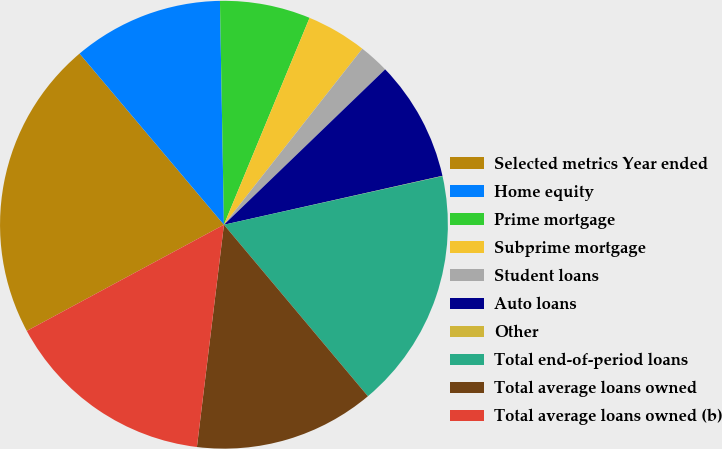Convert chart to OTSL. <chart><loc_0><loc_0><loc_500><loc_500><pie_chart><fcel>Selected metrics Year ended<fcel>Home equity<fcel>Prime mortgage<fcel>Subprime mortgage<fcel>Student loans<fcel>Auto loans<fcel>Other<fcel>Total end-of-period loans<fcel>Total average loans owned<fcel>Total average loans owned (b)<nl><fcel>21.71%<fcel>10.87%<fcel>6.53%<fcel>4.36%<fcel>2.19%<fcel>8.7%<fcel>0.02%<fcel>17.37%<fcel>13.04%<fcel>15.21%<nl></chart> 